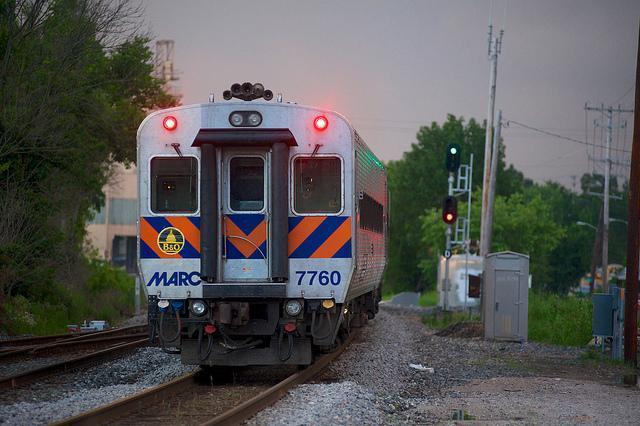How many trains are shown?
Give a very brief answer. 1. 